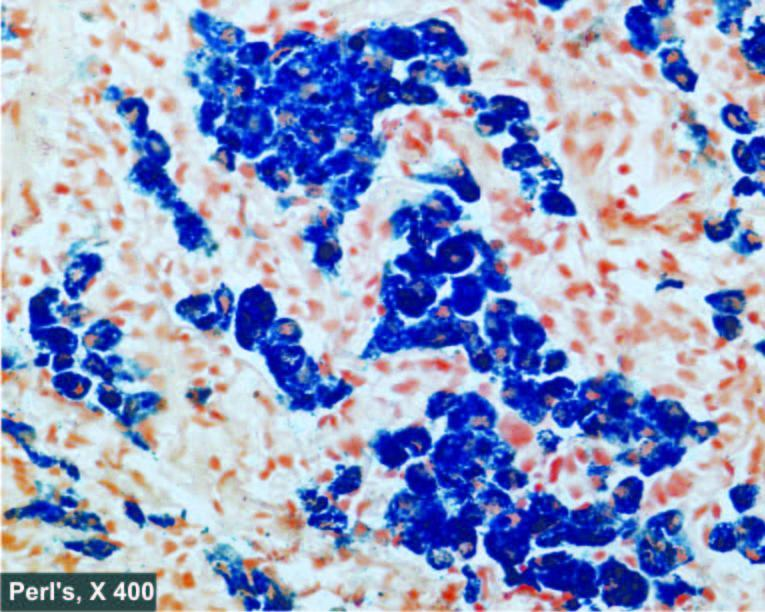what are seen as prussian blue granules?
Answer the question using a single word or phrase. Haemosiderin pigment in the cytoplasm of hepatocytes granules 